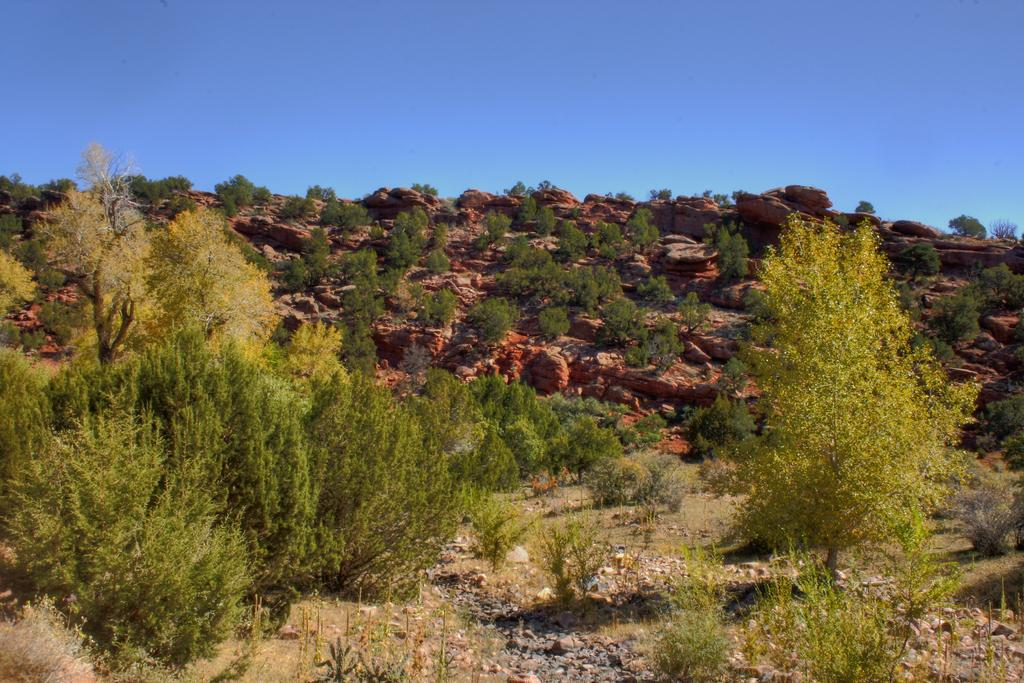What type of natural landform can be seen in the image? There are mountains in the image. What type of vegetation is present in the image? Trees, grass, and plants are visible in the image. What can be found at the top of the mountain? There are stones at the top of the mountain. What is visible at the top of the image? The sky is visible at the top of the image. What type of cord is used to tie the nose in the image? There is no mention of a nose or a cord in the image; it features mountains, trees, grass, plants, and stones at the top of the mountain. 